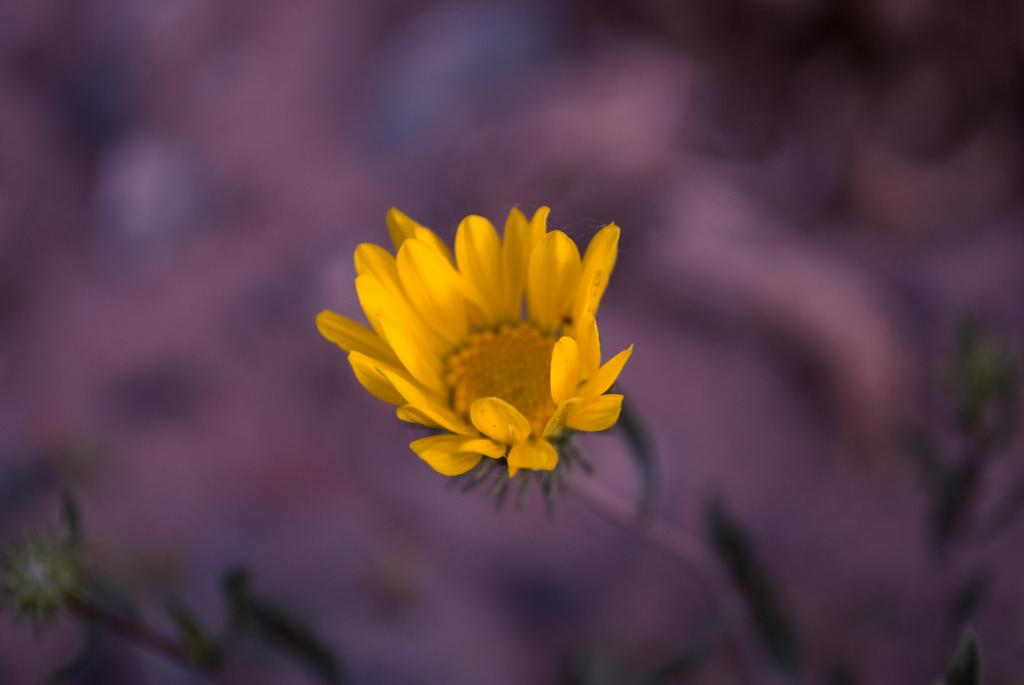What is the main subject of the image? There is a flower in the image. Can you describe the flower's structure? The flower has a stem. What can be observed about the background of the image? The background of the image is blurred. What type of committee can be seen discussing the flower in the image? There is no committee present in the image, and the flower is not being discussed by any group. 